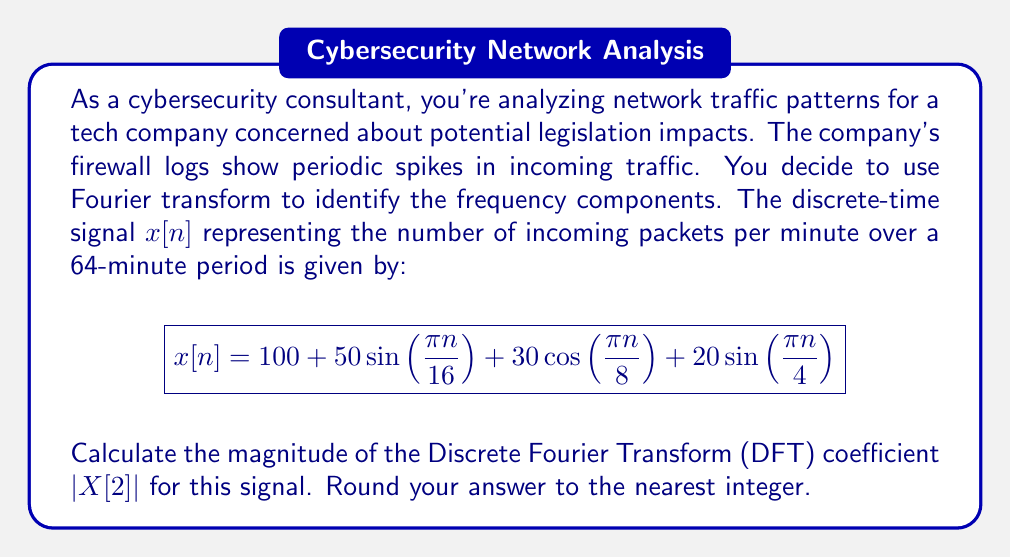Help me with this question. Let's approach this step-by-step:

1) The DFT of a signal $x[n]$ of length $N$ is given by:

   $$X[k] = \sum_{n=0}^{N-1} x[n]e^{-j2\pi kn/N}$$

2) In this case, $N = 64$ (64-minute period), and we're interested in $X[2]$.

3) Let's break down $x[n]$ into its components:
   - DC component: $100$
   - First sinusoid: $50\sin(\frac{\pi n}{16})$
   - Second sinusoid: $30\cos(\frac{\pi n}{8})$
   - Third sinusoid: $20\sin(\frac{\pi n}{4})$

4) The DC component ($100$) doesn't contribute to $X[2]$ as it only affects $X[0]$.

5) For the sinusoids, we need to consider their frequencies:
   - $\frac{\pi}{16}$ corresponds to $k=2$ in the DFT
   - $\frac{\pi}{8}$ corresponds to $k=4$ in the DFT
   - $\frac{\pi}{4}$ corresponds to $k=8$ in the DFT

6) Only the first sinusoid contributes to $X[2]$. We can express it as:

   $$50\sin(\frac{\pi n}{16}) = \frac{50}{2j}(e^{j\pi n/16} - e^{-j\pi n/16})$$

7) The contribution to $X[2]$ is:

   $$X[2] = \frac{50}{2j} \cdot 64 = 1600j$$

8) The magnitude of $X[2]$ is:

   $$|X[2]| = \sqrt{0^2 + 1600^2} = 1600$$

Therefore, the magnitude of the DFT coefficient $|X[2]|$ is 1600.
Answer: 1600 